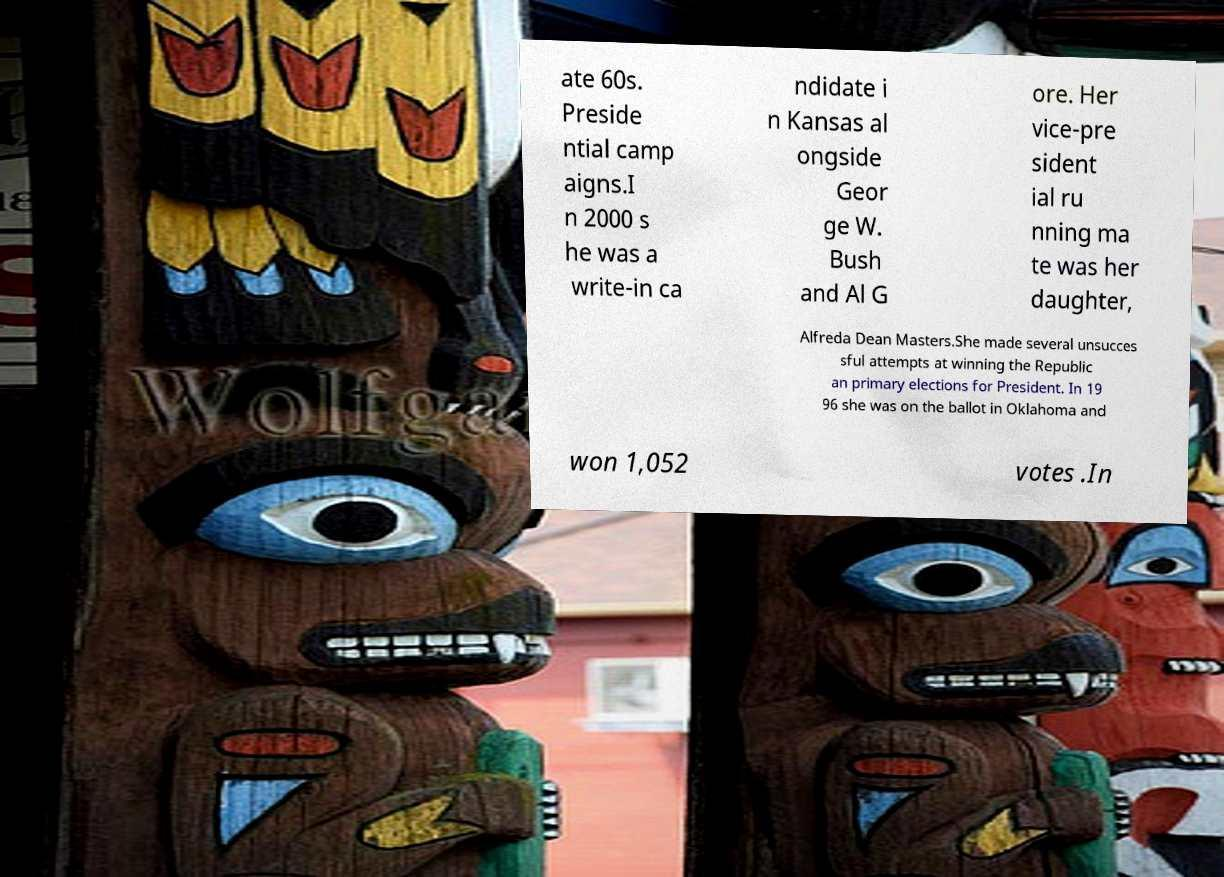Could you extract and type out the text from this image? ate 60s. Preside ntial camp aigns.I n 2000 s he was a write-in ca ndidate i n Kansas al ongside Geor ge W. Bush and Al G ore. Her vice-pre sident ial ru nning ma te was her daughter, Alfreda Dean Masters.She made several unsucces sful attempts at winning the Republic an primary elections for President. In 19 96 she was on the ballot in Oklahoma and won 1,052 votes .In 